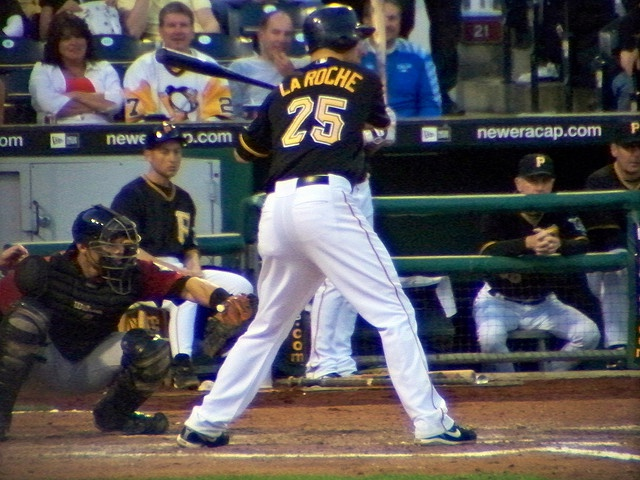Describe the objects in this image and their specific colors. I can see people in black, lavender, darkgray, and navy tones, people in black, gray, and maroon tones, people in black, gray, and darkgray tones, people in black, lightgray, gray, and navy tones, and people in black, gray, darkgray, and tan tones in this image. 